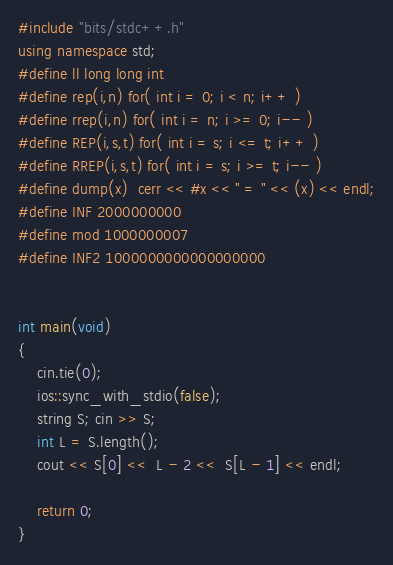<code> <loc_0><loc_0><loc_500><loc_500><_C++_>#include "bits/stdc++.h"
using namespace std;
#define ll long long int
#define rep(i,n) for( int i = 0; i < n; i++ )
#define rrep(i,n) for( int i = n; i >= 0; i-- )
#define REP(i,s,t) for( int i = s; i <= t; i++ )
#define RREP(i,s,t) for( int i = s; i >= t; i-- )
#define dump(x)  cerr << #x << " = " << (x) << endl;
#define INF 2000000000
#define mod 1000000007
#define INF2 1000000000000000000


int main(void)
{
    cin.tie(0);
    ios::sync_with_stdio(false);
    string S; cin >> S;
    int L = S.length();
    cout << S[0] <<  L - 2 <<  S[L - 1] << endl;

    return 0;
}
</code> 